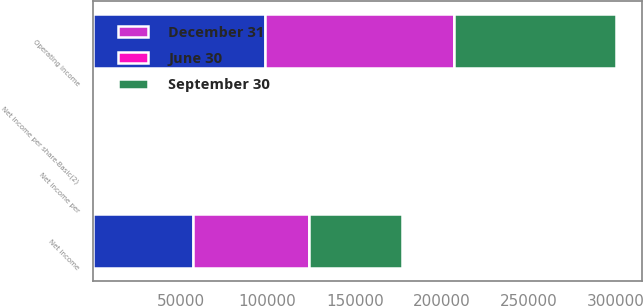Convert chart. <chart><loc_0><loc_0><loc_500><loc_500><stacked_bar_chart><ecel><fcel>Operating income<fcel>Net income<fcel>Net income per share-Basic(2)<fcel>Net income per<nl><fcel>nan<fcel>98391<fcel>57274<fcel>0.32<fcel>0.31<nl><fcel>September 30<fcel>93010<fcel>53341<fcel>0.3<fcel>0.29<nl><fcel>June 30<fcel>1<fcel>1<fcel>1<fcel>1<nl><fcel>December 31<fcel>108557<fcel>66699<fcel>0.37<fcel>0.36<nl></chart> 